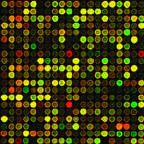s genetic analysis of cancers being utilized to identify mutations that can be targeted by drugs?
Answer the question using a single word or phrase. Yes 